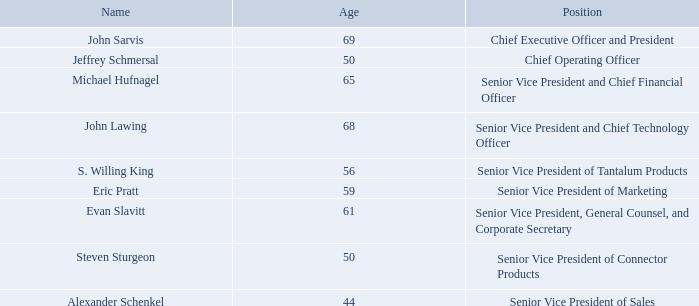Executive Officers of the Registrant
Our executive officers are appointed annually by our Board of Directors or, in some cases, appointed in accordance with our bylaws. Each officer holds office until
the next annual appointment of officers or until a successor has been duly appointed and qualified, or until the officer’s death or resignation, or until the officer has
otherwise been removed in accordance with our bylaws. The following table provides certain information regarding the current executive officers of the Company.
John Sarvis
Chief Executive Officer and President since April 2015. Chairman of the Board since 2016. Vice President of Ceramic Products from 2005 to 2015. Divisional Vice President
– Ceramics Division from 1998 to 2005. Prior to 1998, held various Marketing and Operational positions. Employed by the Company since 1973
Jeffrey Schmersal
Chief Operating Officer since April 2018. Senior Vice President since 2017. Divisional Vice President of Specialty Products from 2014 to 2017. Global Business Manager of
various product groups from 2006 to 2014. Prior to 2006, held various Quality and Supply Chain positions. Employed by the Company since 1994.
Michael Hufnagel
Chief Financial Officer since July 2018. Vice President of Corporate Finance since 2016. Director of Corporate Finance from 2015 to 2016. Director of Accounting and
Reporting from 2002 to 2015. Employed by the Company since 2002.
John Lawing
Senior Vice President and Chief Technology Officer since 2015. Vice President and Chief Technology Officer from April 2014 to 2015. President and Chief Operating
Officer from 2013 to March 2014. Vice President of Advanced Products from 2005 to April 2013. Divisional Vice President of Advanced Products from 2002 to 2005 and
Divisional Vice President of Leaded Products from 1997 to 2002. Prior to 1997, held positions in Engineering, Technical, Operational, and Plant management. Employed by
the Company since 1981.
S. Willing King
Senior Vice President of Tantalum Products since 2015. Vice President of Tantalum Products from 2013 to 2015. Deputy General Manager of Tantalum Products from 2012
to 2013. Vice President of Product Marketing from 2004 to 2012. Director of Product Marketing from 2000 to 2004. Prior to 2000, held positions in Technical Service, Sales,
and Marketing. Employed by the Company since 1984.
Who is the Chief Executive Officer and President of the company? John sarvis. Who is the Chief Operating Officer of the company? Jeffrey schmersal. Who is the Senior Vice President and Chief Financial of the company? Michael hufnagel. What is the average age of the company's Senior Vice Presidents? (65 + 68 + 56 + 59 + 61 + 50 + 44)/7 
Answer: 57.57. How many executive officers are there in the company?  John Sarvis ## Jeffrey Schmersal ## Michael Hufnagel ## John Lawing ## S. Willing King ## Eric Pratt ## Evan Slavitt ## Steven Sturgeon ## Alexander Schenkel
Answer: 9. How many Senior Vice Presidents are there in the company? Michael Hufnagel ## John Lawing ## S. Willing King ## Eric Pratt ## Evan Slavitt ## Steven Sturgeon ## Alexander Schenkel
Answer: 7. 